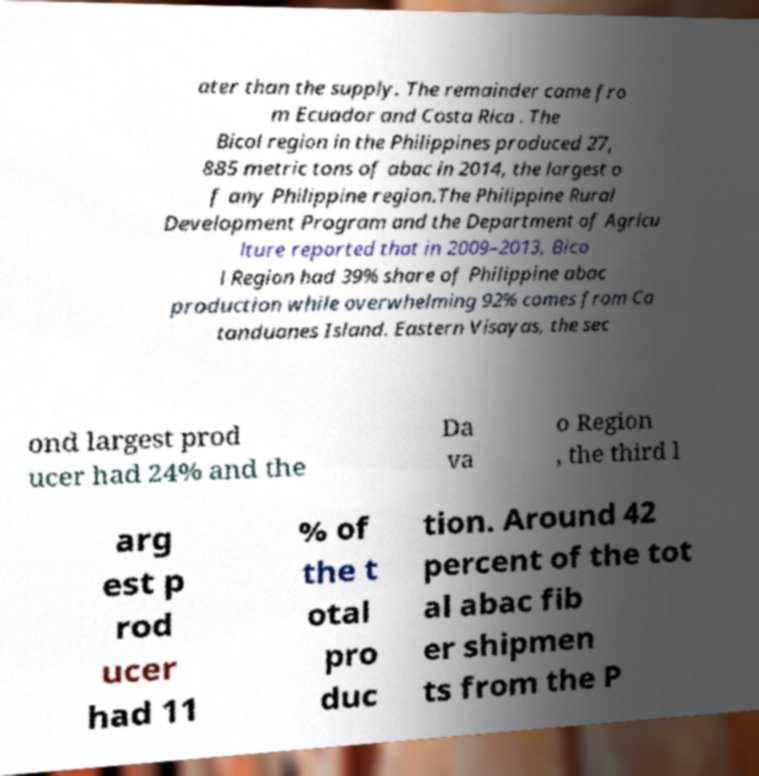For documentation purposes, I need the text within this image transcribed. Could you provide that? ater than the supply. The remainder came fro m Ecuador and Costa Rica . The Bicol region in the Philippines produced 27, 885 metric tons of abac in 2014, the largest o f any Philippine region.The Philippine Rural Development Program and the Department of Agricu lture reported that in 2009–2013, Bico l Region had 39% share of Philippine abac production while overwhelming 92% comes from Ca tanduanes Island. Eastern Visayas, the sec ond largest prod ucer had 24% and the Da va o Region , the third l arg est p rod ucer had 11 % of the t otal pro duc tion. Around 42 percent of the tot al abac fib er shipmen ts from the P 